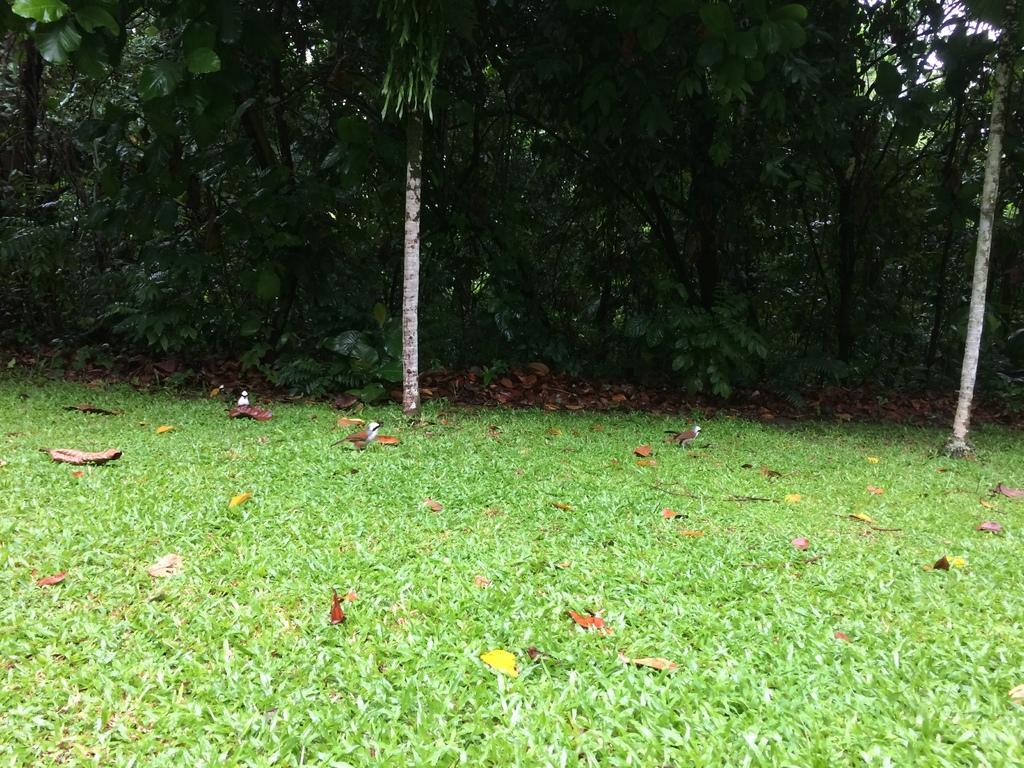In one or two sentences, can you explain what this image depicts? On the ground there is grass. Also there are leaves and birds on the ground. In the background there are trees. 